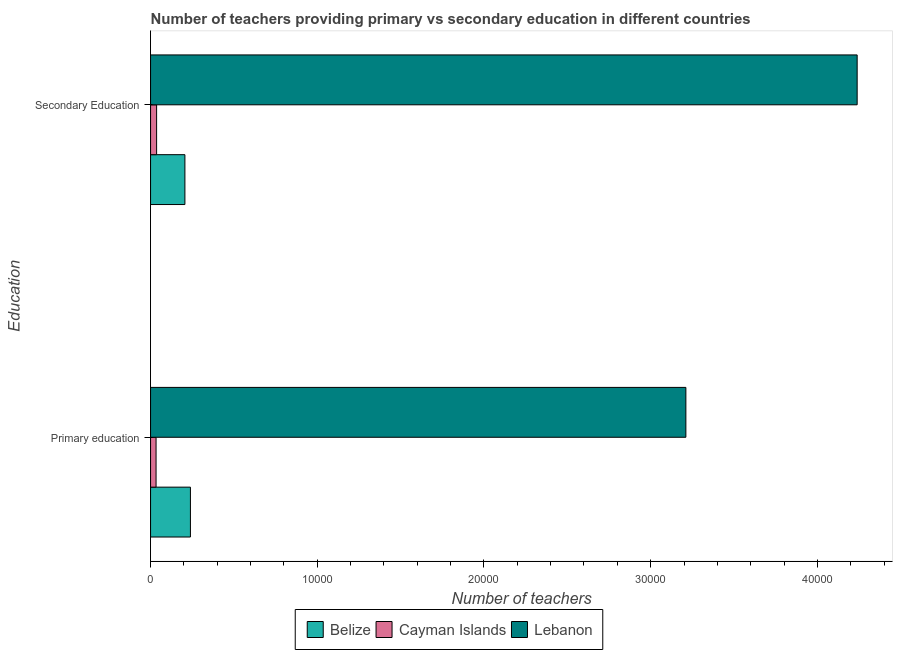How many groups of bars are there?
Your answer should be compact. 2. How many bars are there on the 2nd tick from the bottom?
Ensure brevity in your answer.  3. What is the number of primary teachers in Belize?
Ensure brevity in your answer.  2391. Across all countries, what is the maximum number of secondary teachers?
Your answer should be very brief. 4.24e+04. Across all countries, what is the minimum number of primary teachers?
Your answer should be compact. 330. In which country was the number of primary teachers maximum?
Provide a short and direct response. Lebanon. In which country was the number of secondary teachers minimum?
Your answer should be very brief. Cayman Islands. What is the total number of primary teachers in the graph?
Give a very brief answer. 3.48e+04. What is the difference between the number of secondary teachers in Lebanon and that in Cayman Islands?
Provide a succinct answer. 4.20e+04. What is the difference between the number of primary teachers in Belize and the number of secondary teachers in Lebanon?
Give a very brief answer. -4.00e+04. What is the average number of secondary teachers per country?
Your answer should be very brief. 1.49e+04. What is the difference between the number of secondary teachers and number of primary teachers in Cayman Islands?
Your answer should be very brief. 33. What is the ratio of the number of secondary teachers in Cayman Islands to that in Lebanon?
Provide a short and direct response. 0.01. What does the 3rd bar from the top in Primary education represents?
Make the answer very short. Belize. What does the 1st bar from the bottom in Secondary Education represents?
Keep it short and to the point. Belize. What is the difference between two consecutive major ticks on the X-axis?
Offer a very short reply. 10000. Are the values on the major ticks of X-axis written in scientific E-notation?
Your response must be concise. No. Does the graph contain any zero values?
Your answer should be very brief. No. What is the title of the graph?
Ensure brevity in your answer.  Number of teachers providing primary vs secondary education in different countries. What is the label or title of the X-axis?
Provide a succinct answer. Number of teachers. What is the label or title of the Y-axis?
Your answer should be compact. Education. What is the Number of teachers in Belize in Primary education?
Your response must be concise. 2391. What is the Number of teachers in Cayman Islands in Primary education?
Ensure brevity in your answer.  330. What is the Number of teachers of Lebanon in Primary education?
Give a very brief answer. 3.21e+04. What is the Number of teachers in Belize in Secondary Education?
Give a very brief answer. 2060. What is the Number of teachers in Cayman Islands in Secondary Education?
Give a very brief answer. 363. What is the Number of teachers in Lebanon in Secondary Education?
Provide a short and direct response. 4.24e+04. Across all Education, what is the maximum Number of teachers in Belize?
Provide a short and direct response. 2391. Across all Education, what is the maximum Number of teachers in Cayman Islands?
Ensure brevity in your answer.  363. Across all Education, what is the maximum Number of teachers in Lebanon?
Ensure brevity in your answer.  4.24e+04. Across all Education, what is the minimum Number of teachers of Belize?
Ensure brevity in your answer.  2060. Across all Education, what is the minimum Number of teachers of Cayman Islands?
Make the answer very short. 330. Across all Education, what is the minimum Number of teachers in Lebanon?
Make the answer very short. 3.21e+04. What is the total Number of teachers of Belize in the graph?
Your response must be concise. 4451. What is the total Number of teachers of Cayman Islands in the graph?
Give a very brief answer. 693. What is the total Number of teachers of Lebanon in the graph?
Give a very brief answer. 7.45e+04. What is the difference between the Number of teachers of Belize in Primary education and that in Secondary Education?
Ensure brevity in your answer.  331. What is the difference between the Number of teachers of Cayman Islands in Primary education and that in Secondary Education?
Your response must be concise. -33. What is the difference between the Number of teachers in Lebanon in Primary education and that in Secondary Education?
Provide a short and direct response. -1.03e+04. What is the difference between the Number of teachers of Belize in Primary education and the Number of teachers of Cayman Islands in Secondary Education?
Provide a short and direct response. 2028. What is the difference between the Number of teachers in Belize in Primary education and the Number of teachers in Lebanon in Secondary Education?
Make the answer very short. -4.00e+04. What is the difference between the Number of teachers of Cayman Islands in Primary education and the Number of teachers of Lebanon in Secondary Education?
Your answer should be compact. -4.21e+04. What is the average Number of teachers in Belize per Education?
Your answer should be very brief. 2225.5. What is the average Number of teachers in Cayman Islands per Education?
Provide a short and direct response. 346.5. What is the average Number of teachers in Lebanon per Education?
Offer a terse response. 3.72e+04. What is the difference between the Number of teachers of Belize and Number of teachers of Cayman Islands in Primary education?
Provide a succinct answer. 2061. What is the difference between the Number of teachers in Belize and Number of teachers in Lebanon in Primary education?
Your answer should be compact. -2.97e+04. What is the difference between the Number of teachers in Cayman Islands and Number of teachers in Lebanon in Primary education?
Your answer should be very brief. -3.18e+04. What is the difference between the Number of teachers of Belize and Number of teachers of Cayman Islands in Secondary Education?
Your answer should be very brief. 1697. What is the difference between the Number of teachers of Belize and Number of teachers of Lebanon in Secondary Education?
Offer a very short reply. -4.03e+04. What is the difference between the Number of teachers in Cayman Islands and Number of teachers in Lebanon in Secondary Education?
Give a very brief answer. -4.20e+04. What is the ratio of the Number of teachers of Belize in Primary education to that in Secondary Education?
Offer a very short reply. 1.16. What is the ratio of the Number of teachers in Cayman Islands in Primary education to that in Secondary Education?
Keep it short and to the point. 0.91. What is the ratio of the Number of teachers in Lebanon in Primary education to that in Secondary Education?
Keep it short and to the point. 0.76. What is the difference between the highest and the second highest Number of teachers of Belize?
Provide a succinct answer. 331. What is the difference between the highest and the second highest Number of teachers in Lebanon?
Your response must be concise. 1.03e+04. What is the difference between the highest and the lowest Number of teachers in Belize?
Give a very brief answer. 331. What is the difference between the highest and the lowest Number of teachers in Cayman Islands?
Provide a short and direct response. 33. What is the difference between the highest and the lowest Number of teachers of Lebanon?
Your answer should be very brief. 1.03e+04. 